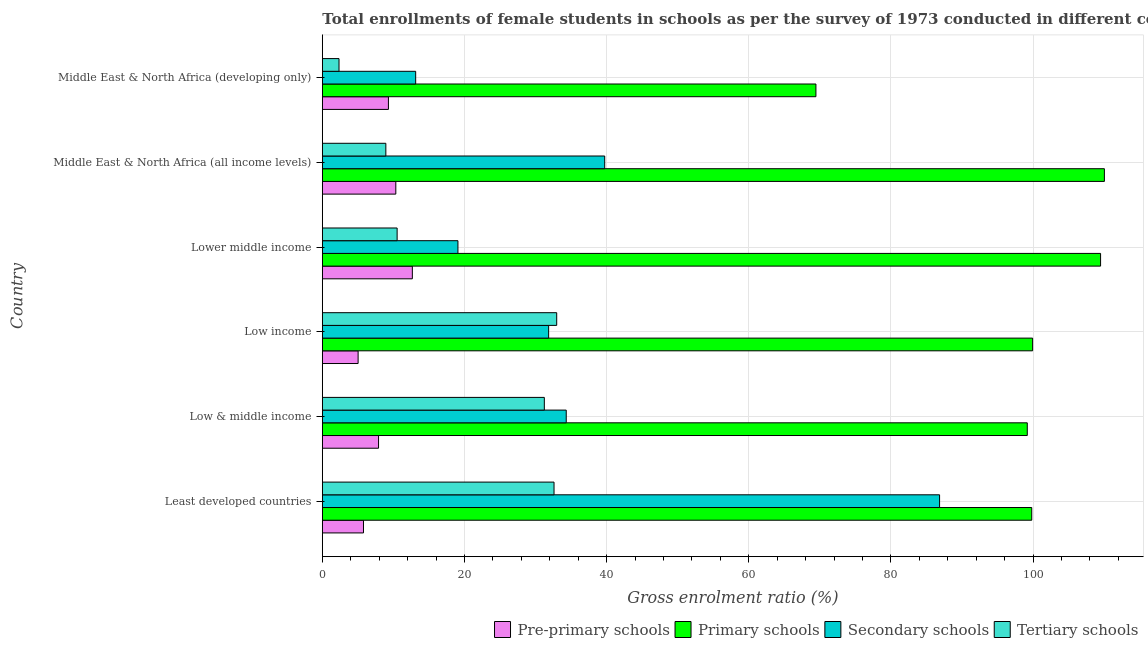How many groups of bars are there?
Offer a very short reply. 6. Are the number of bars per tick equal to the number of legend labels?
Offer a very short reply. Yes. How many bars are there on the 4th tick from the bottom?
Your answer should be very brief. 4. What is the label of the 1st group of bars from the top?
Your answer should be compact. Middle East & North Africa (developing only). In how many cases, is the number of bars for a given country not equal to the number of legend labels?
Offer a terse response. 0. What is the gross enrolment ratio(female) in primary schools in Low income?
Your answer should be very brief. 99.94. Across all countries, what is the maximum gross enrolment ratio(female) in secondary schools?
Make the answer very short. 86.85. Across all countries, what is the minimum gross enrolment ratio(female) in tertiary schools?
Offer a very short reply. 2.35. In which country was the gross enrolment ratio(female) in pre-primary schools maximum?
Give a very brief answer. Lower middle income. In which country was the gross enrolment ratio(female) in secondary schools minimum?
Give a very brief answer. Middle East & North Africa (developing only). What is the total gross enrolment ratio(female) in pre-primary schools in the graph?
Ensure brevity in your answer.  51.04. What is the difference between the gross enrolment ratio(female) in pre-primary schools in Low income and that in Lower middle income?
Your response must be concise. -7.63. What is the difference between the gross enrolment ratio(female) in secondary schools in Low income and the gross enrolment ratio(female) in primary schools in Middle East & North Africa (developing only)?
Provide a short and direct response. -37.61. What is the average gross enrolment ratio(female) in pre-primary schools per country?
Your answer should be very brief. 8.51. What is the difference between the gross enrolment ratio(female) in tertiary schools and gross enrolment ratio(female) in secondary schools in Low & middle income?
Offer a terse response. -3.08. In how many countries, is the gross enrolment ratio(female) in secondary schools greater than 64 %?
Your response must be concise. 1. What is the ratio of the gross enrolment ratio(female) in tertiary schools in Middle East & North Africa (all income levels) to that in Middle East & North Africa (developing only)?
Provide a succinct answer. 3.81. What is the difference between the highest and the second highest gross enrolment ratio(female) in tertiary schools?
Provide a short and direct response. 0.38. What is the difference between the highest and the lowest gross enrolment ratio(female) in primary schools?
Offer a very short reply. 40.59. Is the sum of the gross enrolment ratio(female) in tertiary schools in Low & middle income and Middle East & North Africa (all income levels) greater than the maximum gross enrolment ratio(female) in primary schools across all countries?
Offer a very short reply. No. Is it the case that in every country, the sum of the gross enrolment ratio(female) in tertiary schools and gross enrolment ratio(female) in primary schools is greater than the sum of gross enrolment ratio(female) in secondary schools and gross enrolment ratio(female) in pre-primary schools?
Your answer should be compact. Yes. What does the 4th bar from the top in Middle East & North Africa (developing only) represents?
Your answer should be compact. Pre-primary schools. What does the 3rd bar from the bottom in Middle East & North Africa (all income levels) represents?
Offer a very short reply. Secondary schools. Is it the case that in every country, the sum of the gross enrolment ratio(female) in pre-primary schools and gross enrolment ratio(female) in primary schools is greater than the gross enrolment ratio(female) in secondary schools?
Keep it short and to the point. Yes. How many countries are there in the graph?
Offer a terse response. 6. Are the values on the major ticks of X-axis written in scientific E-notation?
Keep it short and to the point. No. Does the graph contain any zero values?
Ensure brevity in your answer.  No. Does the graph contain grids?
Provide a short and direct response. Yes. What is the title of the graph?
Offer a very short reply. Total enrollments of female students in schools as per the survey of 1973 conducted in different countries. Does "Rule based governance" appear as one of the legend labels in the graph?
Your response must be concise. No. What is the label or title of the X-axis?
Provide a succinct answer. Gross enrolment ratio (%). What is the Gross enrolment ratio (%) of Pre-primary schools in Least developed countries?
Ensure brevity in your answer.  5.79. What is the Gross enrolment ratio (%) of Primary schools in Least developed countries?
Make the answer very short. 99.82. What is the Gross enrolment ratio (%) of Secondary schools in Least developed countries?
Provide a short and direct response. 86.85. What is the Gross enrolment ratio (%) in Tertiary schools in Least developed countries?
Offer a very short reply. 32.6. What is the Gross enrolment ratio (%) in Pre-primary schools in Low & middle income?
Offer a terse response. 7.91. What is the Gross enrolment ratio (%) in Primary schools in Low & middle income?
Make the answer very short. 99.19. What is the Gross enrolment ratio (%) in Secondary schools in Low & middle income?
Your answer should be very brief. 34.32. What is the Gross enrolment ratio (%) in Tertiary schools in Low & middle income?
Your answer should be very brief. 31.24. What is the Gross enrolment ratio (%) of Pre-primary schools in Low income?
Make the answer very short. 5.04. What is the Gross enrolment ratio (%) of Primary schools in Low income?
Offer a terse response. 99.94. What is the Gross enrolment ratio (%) of Secondary schools in Low income?
Make the answer very short. 31.84. What is the Gross enrolment ratio (%) in Tertiary schools in Low income?
Your answer should be very brief. 32.98. What is the Gross enrolment ratio (%) in Pre-primary schools in Lower middle income?
Offer a terse response. 12.67. What is the Gross enrolment ratio (%) in Primary schools in Lower middle income?
Ensure brevity in your answer.  109.51. What is the Gross enrolment ratio (%) of Secondary schools in Lower middle income?
Your response must be concise. 19.08. What is the Gross enrolment ratio (%) in Tertiary schools in Lower middle income?
Your answer should be very brief. 10.52. What is the Gross enrolment ratio (%) in Pre-primary schools in Middle East & North Africa (all income levels)?
Ensure brevity in your answer.  10.34. What is the Gross enrolment ratio (%) of Primary schools in Middle East & North Africa (all income levels)?
Offer a very short reply. 110.04. What is the Gross enrolment ratio (%) in Secondary schools in Middle East & North Africa (all income levels)?
Keep it short and to the point. 39.73. What is the Gross enrolment ratio (%) in Tertiary schools in Middle East & North Africa (all income levels)?
Ensure brevity in your answer.  8.94. What is the Gross enrolment ratio (%) in Pre-primary schools in Middle East & North Africa (developing only)?
Ensure brevity in your answer.  9.3. What is the Gross enrolment ratio (%) of Primary schools in Middle East & North Africa (developing only)?
Your answer should be compact. 69.45. What is the Gross enrolment ratio (%) of Secondary schools in Middle East & North Africa (developing only)?
Ensure brevity in your answer.  13.13. What is the Gross enrolment ratio (%) of Tertiary schools in Middle East & North Africa (developing only)?
Offer a very short reply. 2.35. Across all countries, what is the maximum Gross enrolment ratio (%) of Pre-primary schools?
Ensure brevity in your answer.  12.67. Across all countries, what is the maximum Gross enrolment ratio (%) in Primary schools?
Offer a very short reply. 110.04. Across all countries, what is the maximum Gross enrolment ratio (%) of Secondary schools?
Give a very brief answer. 86.85. Across all countries, what is the maximum Gross enrolment ratio (%) of Tertiary schools?
Make the answer very short. 32.98. Across all countries, what is the minimum Gross enrolment ratio (%) in Pre-primary schools?
Keep it short and to the point. 5.04. Across all countries, what is the minimum Gross enrolment ratio (%) of Primary schools?
Your answer should be very brief. 69.45. Across all countries, what is the minimum Gross enrolment ratio (%) of Secondary schools?
Ensure brevity in your answer.  13.13. Across all countries, what is the minimum Gross enrolment ratio (%) of Tertiary schools?
Ensure brevity in your answer.  2.35. What is the total Gross enrolment ratio (%) in Pre-primary schools in the graph?
Ensure brevity in your answer.  51.04. What is the total Gross enrolment ratio (%) of Primary schools in the graph?
Provide a succinct answer. 587.96. What is the total Gross enrolment ratio (%) of Secondary schools in the graph?
Your answer should be compact. 224.96. What is the total Gross enrolment ratio (%) in Tertiary schools in the graph?
Keep it short and to the point. 118.63. What is the difference between the Gross enrolment ratio (%) in Pre-primary schools in Least developed countries and that in Low & middle income?
Provide a short and direct response. -2.12. What is the difference between the Gross enrolment ratio (%) in Primary schools in Least developed countries and that in Low & middle income?
Keep it short and to the point. 0.63. What is the difference between the Gross enrolment ratio (%) of Secondary schools in Least developed countries and that in Low & middle income?
Make the answer very short. 52.53. What is the difference between the Gross enrolment ratio (%) in Tertiary schools in Least developed countries and that in Low & middle income?
Make the answer very short. 1.36. What is the difference between the Gross enrolment ratio (%) of Pre-primary schools in Least developed countries and that in Low income?
Give a very brief answer. 0.76. What is the difference between the Gross enrolment ratio (%) of Primary schools in Least developed countries and that in Low income?
Offer a very short reply. -0.12. What is the difference between the Gross enrolment ratio (%) in Secondary schools in Least developed countries and that in Low income?
Your answer should be very brief. 55.01. What is the difference between the Gross enrolment ratio (%) in Tertiary schools in Least developed countries and that in Low income?
Offer a very short reply. -0.38. What is the difference between the Gross enrolment ratio (%) of Pre-primary schools in Least developed countries and that in Lower middle income?
Ensure brevity in your answer.  -6.88. What is the difference between the Gross enrolment ratio (%) of Primary schools in Least developed countries and that in Lower middle income?
Give a very brief answer. -9.68. What is the difference between the Gross enrolment ratio (%) in Secondary schools in Least developed countries and that in Lower middle income?
Ensure brevity in your answer.  67.77. What is the difference between the Gross enrolment ratio (%) in Tertiary schools in Least developed countries and that in Lower middle income?
Your answer should be compact. 22.08. What is the difference between the Gross enrolment ratio (%) of Pre-primary schools in Least developed countries and that in Middle East & North Africa (all income levels)?
Your answer should be compact. -4.55. What is the difference between the Gross enrolment ratio (%) of Primary schools in Least developed countries and that in Middle East & North Africa (all income levels)?
Give a very brief answer. -10.22. What is the difference between the Gross enrolment ratio (%) in Secondary schools in Least developed countries and that in Middle East & North Africa (all income levels)?
Provide a succinct answer. 47.12. What is the difference between the Gross enrolment ratio (%) of Tertiary schools in Least developed countries and that in Middle East & North Africa (all income levels)?
Make the answer very short. 23.66. What is the difference between the Gross enrolment ratio (%) of Pre-primary schools in Least developed countries and that in Middle East & North Africa (developing only)?
Provide a short and direct response. -3.51. What is the difference between the Gross enrolment ratio (%) in Primary schools in Least developed countries and that in Middle East & North Africa (developing only)?
Offer a terse response. 30.37. What is the difference between the Gross enrolment ratio (%) of Secondary schools in Least developed countries and that in Middle East & North Africa (developing only)?
Keep it short and to the point. 73.72. What is the difference between the Gross enrolment ratio (%) in Tertiary schools in Least developed countries and that in Middle East & North Africa (developing only)?
Keep it short and to the point. 30.25. What is the difference between the Gross enrolment ratio (%) in Pre-primary schools in Low & middle income and that in Low income?
Offer a very short reply. 2.87. What is the difference between the Gross enrolment ratio (%) of Primary schools in Low & middle income and that in Low income?
Your response must be concise. -0.75. What is the difference between the Gross enrolment ratio (%) of Secondary schools in Low & middle income and that in Low income?
Make the answer very short. 2.48. What is the difference between the Gross enrolment ratio (%) in Tertiary schools in Low & middle income and that in Low income?
Your answer should be compact. -1.74. What is the difference between the Gross enrolment ratio (%) of Pre-primary schools in Low & middle income and that in Lower middle income?
Keep it short and to the point. -4.76. What is the difference between the Gross enrolment ratio (%) in Primary schools in Low & middle income and that in Lower middle income?
Your answer should be very brief. -10.31. What is the difference between the Gross enrolment ratio (%) in Secondary schools in Low & middle income and that in Lower middle income?
Offer a very short reply. 15.24. What is the difference between the Gross enrolment ratio (%) in Tertiary schools in Low & middle income and that in Lower middle income?
Offer a terse response. 20.71. What is the difference between the Gross enrolment ratio (%) of Pre-primary schools in Low & middle income and that in Middle East & North Africa (all income levels)?
Your answer should be very brief. -2.43. What is the difference between the Gross enrolment ratio (%) of Primary schools in Low & middle income and that in Middle East & North Africa (all income levels)?
Make the answer very short. -10.85. What is the difference between the Gross enrolment ratio (%) in Secondary schools in Low & middle income and that in Middle East & North Africa (all income levels)?
Make the answer very short. -5.41. What is the difference between the Gross enrolment ratio (%) of Tertiary schools in Low & middle income and that in Middle East & North Africa (all income levels)?
Offer a terse response. 22.3. What is the difference between the Gross enrolment ratio (%) in Pre-primary schools in Low & middle income and that in Middle East & North Africa (developing only)?
Make the answer very short. -1.39. What is the difference between the Gross enrolment ratio (%) of Primary schools in Low & middle income and that in Middle East & North Africa (developing only)?
Provide a succinct answer. 29.74. What is the difference between the Gross enrolment ratio (%) in Secondary schools in Low & middle income and that in Middle East & North Africa (developing only)?
Your response must be concise. 21.18. What is the difference between the Gross enrolment ratio (%) of Tertiary schools in Low & middle income and that in Middle East & North Africa (developing only)?
Keep it short and to the point. 28.89. What is the difference between the Gross enrolment ratio (%) of Pre-primary schools in Low income and that in Lower middle income?
Ensure brevity in your answer.  -7.63. What is the difference between the Gross enrolment ratio (%) in Primary schools in Low income and that in Lower middle income?
Offer a very short reply. -9.56. What is the difference between the Gross enrolment ratio (%) in Secondary schools in Low income and that in Lower middle income?
Offer a very short reply. 12.76. What is the difference between the Gross enrolment ratio (%) in Tertiary schools in Low income and that in Lower middle income?
Ensure brevity in your answer.  22.45. What is the difference between the Gross enrolment ratio (%) in Pre-primary schools in Low income and that in Middle East & North Africa (all income levels)?
Keep it short and to the point. -5.3. What is the difference between the Gross enrolment ratio (%) of Primary schools in Low income and that in Middle East & North Africa (all income levels)?
Ensure brevity in your answer.  -10.1. What is the difference between the Gross enrolment ratio (%) of Secondary schools in Low income and that in Middle East & North Africa (all income levels)?
Ensure brevity in your answer.  -7.89. What is the difference between the Gross enrolment ratio (%) in Tertiary schools in Low income and that in Middle East & North Africa (all income levels)?
Provide a succinct answer. 24.04. What is the difference between the Gross enrolment ratio (%) in Pre-primary schools in Low income and that in Middle East & North Africa (developing only)?
Offer a terse response. -4.26. What is the difference between the Gross enrolment ratio (%) in Primary schools in Low income and that in Middle East & North Africa (developing only)?
Offer a terse response. 30.49. What is the difference between the Gross enrolment ratio (%) in Secondary schools in Low income and that in Middle East & North Africa (developing only)?
Your answer should be very brief. 18.71. What is the difference between the Gross enrolment ratio (%) of Tertiary schools in Low income and that in Middle East & North Africa (developing only)?
Ensure brevity in your answer.  30.63. What is the difference between the Gross enrolment ratio (%) of Pre-primary schools in Lower middle income and that in Middle East & North Africa (all income levels)?
Give a very brief answer. 2.33. What is the difference between the Gross enrolment ratio (%) of Primary schools in Lower middle income and that in Middle East & North Africa (all income levels)?
Your answer should be very brief. -0.54. What is the difference between the Gross enrolment ratio (%) of Secondary schools in Lower middle income and that in Middle East & North Africa (all income levels)?
Your answer should be very brief. -20.65. What is the difference between the Gross enrolment ratio (%) of Tertiary schools in Lower middle income and that in Middle East & North Africa (all income levels)?
Your answer should be compact. 1.59. What is the difference between the Gross enrolment ratio (%) in Pre-primary schools in Lower middle income and that in Middle East & North Africa (developing only)?
Offer a very short reply. 3.37. What is the difference between the Gross enrolment ratio (%) in Primary schools in Lower middle income and that in Middle East & North Africa (developing only)?
Offer a very short reply. 40.05. What is the difference between the Gross enrolment ratio (%) of Secondary schools in Lower middle income and that in Middle East & North Africa (developing only)?
Offer a terse response. 5.95. What is the difference between the Gross enrolment ratio (%) in Tertiary schools in Lower middle income and that in Middle East & North Africa (developing only)?
Ensure brevity in your answer.  8.18. What is the difference between the Gross enrolment ratio (%) in Pre-primary schools in Middle East & North Africa (all income levels) and that in Middle East & North Africa (developing only)?
Your response must be concise. 1.04. What is the difference between the Gross enrolment ratio (%) of Primary schools in Middle East & North Africa (all income levels) and that in Middle East & North Africa (developing only)?
Provide a succinct answer. 40.59. What is the difference between the Gross enrolment ratio (%) of Secondary schools in Middle East & North Africa (all income levels) and that in Middle East & North Africa (developing only)?
Give a very brief answer. 26.6. What is the difference between the Gross enrolment ratio (%) of Tertiary schools in Middle East & North Africa (all income levels) and that in Middle East & North Africa (developing only)?
Keep it short and to the point. 6.59. What is the difference between the Gross enrolment ratio (%) of Pre-primary schools in Least developed countries and the Gross enrolment ratio (%) of Primary schools in Low & middle income?
Your answer should be very brief. -93.4. What is the difference between the Gross enrolment ratio (%) in Pre-primary schools in Least developed countries and the Gross enrolment ratio (%) in Secondary schools in Low & middle income?
Provide a short and direct response. -28.53. What is the difference between the Gross enrolment ratio (%) of Pre-primary schools in Least developed countries and the Gross enrolment ratio (%) of Tertiary schools in Low & middle income?
Offer a very short reply. -25.45. What is the difference between the Gross enrolment ratio (%) of Primary schools in Least developed countries and the Gross enrolment ratio (%) of Secondary schools in Low & middle income?
Your answer should be compact. 65.5. What is the difference between the Gross enrolment ratio (%) in Primary schools in Least developed countries and the Gross enrolment ratio (%) in Tertiary schools in Low & middle income?
Provide a succinct answer. 68.58. What is the difference between the Gross enrolment ratio (%) in Secondary schools in Least developed countries and the Gross enrolment ratio (%) in Tertiary schools in Low & middle income?
Make the answer very short. 55.62. What is the difference between the Gross enrolment ratio (%) in Pre-primary schools in Least developed countries and the Gross enrolment ratio (%) in Primary schools in Low income?
Your answer should be compact. -94.15. What is the difference between the Gross enrolment ratio (%) of Pre-primary schools in Least developed countries and the Gross enrolment ratio (%) of Secondary schools in Low income?
Provide a short and direct response. -26.05. What is the difference between the Gross enrolment ratio (%) in Pre-primary schools in Least developed countries and the Gross enrolment ratio (%) in Tertiary schools in Low income?
Make the answer very short. -27.19. What is the difference between the Gross enrolment ratio (%) in Primary schools in Least developed countries and the Gross enrolment ratio (%) in Secondary schools in Low income?
Your answer should be compact. 67.98. What is the difference between the Gross enrolment ratio (%) of Primary schools in Least developed countries and the Gross enrolment ratio (%) of Tertiary schools in Low income?
Ensure brevity in your answer.  66.84. What is the difference between the Gross enrolment ratio (%) in Secondary schools in Least developed countries and the Gross enrolment ratio (%) in Tertiary schools in Low income?
Provide a short and direct response. 53.87. What is the difference between the Gross enrolment ratio (%) of Pre-primary schools in Least developed countries and the Gross enrolment ratio (%) of Primary schools in Lower middle income?
Your answer should be very brief. -103.71. What is the difference between the Gross enrolment ratio (%) in Pre-primary schools in Least developed countries and the Gross enrolment ratio (%) in Secondary schools in Lower middle income?
Keep it short and to the point. -13.29. What is the difference between the Gross enrolment ratio (%) in Pre-primary schools in Least developed countries and the Gross enrolment ratio (%) in Tertiary schools in Lower middle income?
Offer a very short reply. -4.73. What is the difference between the Gross enrolment ratio (%) of Primary schools in Least developed countries and the Gross enrolment ratio (%) of Secondary schools in Lower middle income?
Provide a succinct answer. 80.74. What is the difference between the Gross enrolment ratio (%) in Primary schools in Least developed countries and the Gross enrolment ratio (%) in Tertiary schools in Lower middle income?
Your answer should be compact. 89.3. What is the difference between the Gross enrolment ratio (%) of Secondary schools in Least developed countries and the Gross enrolment ratio (%) of Tertiary schools in Lower middle income?
Ensure brevity in your answer.  76.33. What is the difference between the Gross enrolment ratio (%) in Pre-primary schools in Least developed countries and the Gross enrolment ratio (%) in Primary schools in Middle East & North Africa (all income levels)?
Offer a very short reply. -104.25. What is the difference between the Gross enrolment ratio (%) of Pre-primary schools in Least developed countries and the Gross enrolment ratio (%) of Secondary schools in Middle East & North Africa (all income levels)?
Your answer should be compact. -33.94. What is the difference between the Gross enrolment ratio (%) of Pre-primary schools in Least developed countries and the Gross enrolment ratio (%) of Tertiary schools in Middle East & North Africa (all income levels)?
Provide a short and direct response. -3.15. What is the difference between the Gross enrolment ratio (%) of Primary schools in Least developed countries and the Gross enrolment ratio (%) of Secondary schools in Middle East & North Africa (all income levels)?
Make the answer very short. 60.09. What is the difference between the Gross enrolment ratio (%) in Primary schools in Least developed countries and the Gross enrolment ratio (%) in Tertiary schools in Middle East & North Africa (all income levels)?
Provide a succinct answer. 90.88. What is the difference between the Gross enrolment ratio (%) of Secondary schools in Least developed countries and the Gross enrolment ratio (%) of Tertiary schools in Middle East & North Africa (all income levels)?
Ensure brevity in your answer.  77.91. What is the difference between the Gross enrolment ratio (%) in Pre-primary schools in Least developed countries and the Gross enrolment ratio (%) in Primary schools in Middle East & North Africa (developing only)?
Provide a succinct answer. -63.66. What is the difference between the Gross enrolment ratio (%) of Pre-primary schools in Least developed countries and the Gross enrolment ratio (%) of Secondary schools in Middle East & North Africa (developing only)?
Provide a succinct answer. -7.34. What is the difference between the Gross enrolment ratio (%) in Pre-primary schools in Least developed countries and the Gross enrolment ratio (%) in Tertiary schools in Middle East & North Africa (developing only)?
Offer a very short reply. 3.44. What is the difference between the Gross enrolment ratio (%) of Primary schools in Least developed countries and the Gross enrolment ratio (%) of Secondary schools in Middle East & North Africa (developing only)?
Provide a succinct answer. 86.69. What is the difference between the Gross enrolment ratio (%) in Primary schools in Least developed countries and the Gross enrolment ratio (%) in Tertiary schools in Middle East & North Africa (developing only)?
Your answer should be compact. 97.47. What is the difference between the Gross enrolment ratio (%) in Secondary schools in Least developed countries and the Gross enrolment ratio (%) in Tertiary schools in Middle East & North Africa (developing only)?
Keep it short and to the point. 84.5. What is the difference between the Gross enrolment ratio (%) of Pre-primary schools in Low & middle income and the Gross enrolment ratio (%) of Primary schools in Low income?
Offer a terse response. -92.03. What is the difference between the Gross enrolment ratio (%) of Pre-primary schools in Low & middle income and the Gross enrolment ratio (%) of Secondary schools in Low income?
Your answer should be compact. -23.93. What is the difference between the Gross enrolment ratio (%) in Pre-primary schools in Low & middle income and the Gross enrolment ratio (%) in Tertiary schools in Low income?
Ensure brevity in your answer.  -25.07. What is the difference between the Gross enrolment ratio (%) of Primary schools in Low & middle income and the Gross enrolment ratio (%) of Secondary schools in Low income?
Ensure brevity in your answer.  67.35. What is the difference between the Gross enrolment ratio (%) in Primary schools in Low & middle income and the Gross enrolment ratio (%) in Tertiary schools in Low income?
Provide a short and direct response. 66.21. What is the difference between the Gross enrolment ratio (%) of Secondary schools in Low & middle income and the Gross enrolment ratio (%) of Tertiary schools in Low income?
Make the answer very short. 1.34. What is the difference between the Gross enrolment ratio (%) in Pre-primary schools in Low & middle income and the Gross enrolment ratio (%) in Primary schools in Lower middle income?
Your answer should be very brief. -101.6. What is the difference between the Gross enrolment ratio (%) in Pre-primary schools in Low & middle income and the Gross enrolment ratio (%) in Secondary schools in Lower middle income?
Offer a very short reply. -11.17. What is the difference between the Gross enrolment ratio (%) of Pre-primary schools in Low & middle income and the Gross enrolment ratio (%) of Tertiary schools in Lower middle income?
Your response must be concise. -2.62. What is the difference between the Gross enrolment ratio (%) in Primary schools in Low & middle income and the Gross enrolment ratio (%) in Secondary schools in Lower middle income?
Your answer should be compact. 80.11. What is the difference between the Gross enrolment ratio (%) in Primary schools in Low & middle income and the Gross enrolment ratio (%) in Tertiary schools in Lower middle income?
Offer a very short reply. 88.67. What is the difference between the Gross enrolment ratio (%) of Secondary schools in Low & middle income and the Gross enrolment ratio (%) of Tertiary schools in Lower middle income?
Offer a very short reply. 23.79. What is the difference between the Gross enrolment ratio (%) in Pre-primary schools in Low & middle income and the Gross enrolment ratio (%) in Primary schools in Middle East & North Africa (all income levels)?
Your response must be concise. -102.13. What is the difference between the Gross enrolment ratio (%) in Pre-primary schools in Low & middle income and the Gross enrolment ratio (%) in Secondary schools in Middle East & North Africa (all income levels)?
Give a very brief answer. -31.82. What is the difference between the Gross enrolment ratio (%) in Pre-primary schools in Low & middle income and the Gross enrolment ratio (%) in Tertiary schools in Middle East & North Africa (all income levels)?
Give a very brief answer. -1.03. What is the difference between the Gross enrolment ratio (%) of Primary schools in Low & middle income and the Gross enrolment ratio (%) of Secondary schools in Middle East & North Africa (all income levels)?
Provide a succinct answer. 59.46. What is the difference between the Gross enrolment ratio (%) in Primary schools in Low & middle income and the Gross enrolment ratio (%) in Tertiary schools in Middle East & North Africa (all income levels)?
Provide a succinct answer. 90.25. What is the difference between the Gross enrolment ratio (%) in Secondary schools in Low & middle income and the Gross enrolment ratio (%) in Tertiary schools in Middle East & North Africa (all income levels)?
Your response must be concise. 25.38. What is the difference between the Gross enrolment ratio (%) of Pre-primary schools in Low & middle income and the Gross enrolment ratio (%) of Primary schools in Middle East & North Africa (developing only)?
Your answer should be very brief. -61.54. What is the difference between the Gross enrolment ratio (%) in Pre-primary schools in Low & middle income and the Gross enrolment ratio (%) in Secondary schools in Middle East & North Africa (developing only)?
Your response must be concise. -5.22. What is the difference between the Gross enrolment ratio (%) in Pre-primary schools in Low & middle income and the Gross enrolment ratio (%) in Tertiary schools in Middle East & North Africa (developing only)?
Give a very brief answer. 5.56. What is the difference between the Gross enrolment ratio (%) in Primary schools in Low & middle income and the Gross enrolment ratio (%) in Secondary schools in Middle East & North Africa (developing only)?
Give a very brief answer. 86.06. What is the difference between the Gross enrolment ratio (%) in Primary schools in Low & middle income and the Gross enrolment ratio (%) in Tertiary schools in Middle East & North Africa (developing only)?
Make the answer very short. 96.84. What is the difference between the Gross enrolment ratio (%) in Secondary schools in Low & middle income and the Gross enrolment ratio (%) in Tertiary schools in Middle East & North Africa (developing only)?
Ensure brevity in your answer.  31.97. What is the difference between the Gross enrolment ratio (%) of Pre-primary schools in Low income and the Gross enrolment ratio (%) of Primary schools in Lower middle income?
Your response must be concise. -104.47. What is the difference between the Gross enrolment ratio (%) of Pre-primary schools in Low income and the Gross enrolment ratio (%) of Secondary schools in Lower middle income?
Your answer should be very brief. -14.04. What is the difference between the Gross enrolment ratio (%) of Pre-primary schools in Low income and the Gross enrolment ratio (%) of Tertiary schools in Lower middle income?
Provide a succinct answer. -5.49. What is the difference between the Gross enrolment ratio (%) of Primary schools in Low income and the Gross enrolment ratio (%) of Secondary schools in Lower middle income?
Offer a very short reply. 80.86. What is the difference between the Gross enrolment ratio (%) in Primary schools in Low income and the Gross enrolment ratio (%) in Tertiary schools in Lower middle income?
Your answer should be compact. 89.42. What is the difference between the Gross enrolment ratio (%) in Secondary schools in Low income and the Gross enrolment ratio (%) in Tertiary schools in Lower middle income?
Give a very brief answer. 21.32. What is the difference between the Gross enrolment ratio (%) in Pre-primary schools in Low income and the Gross enrolment ratio (%) in Primary schools in Middle East & North Africa (all income levels)?
Provide a short and direct response. -105.01. What is the difference between the Gross enrolment ratio (%) in Pre-primary schools in Low income and the Gross enrolment ratio (%) in Secondary schools in Middle East & North Africa (all income levels)?
Your answer should be very brief. -34.7. What is the difference between the Gross enrolment ratio (%) of Pre-primary schools in Low income and the Gross enrolment ratio (%) of Tertiary schools in Middle East & North Africa (all income levels)?
Give a very brief answer. -3.9. What is the difference between the Gross enrolment ratio (%) of Primary schools in Low income and the Gross enrolment ratio (%) of Secondary schools in Middle East & North Africa (all income levels)?
Provide a short and direct response. 60.21. What is the difference between the Gross enrolment ratio (%) in Primary schools in Low income and the Gross enrolment ratio (%) in Tertiary schools in Middle East & North Africa (all income levels)?
Offer a terse response. 91.01. What is the difference between the Gross enrolment ratio (%) of Secondary schools in Low income and the Gross enrolment ratio (%) of Tertiary schools in Middle East & North Africa (all income levels)?
Provide a short and direct response. 22.91. What is the difference between the Gross enrolment ratio (%) of Pre-primary schools in Low income and the Gross enrolment ratio (%) of Primary schools in Middle East & North Africa (developing only)?
Give a very brief answer. -64.42. What is the difference between the Gross enrolment ratio (%) of Pre-primary schools in Low income and the Gross enrolment ratio (%) of Secondary schools in Middle East & North Africa (developing only)?
Make the answer very short. -8.1. What is the difference between the Gross enrolment ratio (%) of Pre-primary schools in Low income and the Gross enrolment ratio (%) of Tertiary schools in Middle East & North Africa (developing only)?
Ensure brevity in your answer.  2.69. What is the difference between the Gross enrolment ratio (%) of Primary schools in Low income and the Gross enrolment ratio (%) of Secondary schools in Middle East & North Africa (developing only)?
Your answer should be compact. 86.81. What is the difference between the Gross enrolment ratio (%) in Primary schools in Low income and the Gross enrolment ratio (%) in Tertiary schools in Middle East & North Africa (developing only)?
Give a very brief answer. 97.6. What is the difference between the Gross enrolment ratio (%) of Secondary schools in Low income and the Gross enrolment ratio (%) of Tertiary schools in Middle East & North Africa (developing only)?
Provide a short and direct response. 29.5. What is the difference between the Gross enrolment ratio (%) in Pre-primary schools in Lower middle income and the Gross enrolment ratio (%) in Primary schools in Middle East & North Africa (all income levels)?
Your answer should be very brief. -97.38. What is the difference between the Gross enrolment ratio (%) of Pre-primary schools in Lower middle income and the Gross enrolment ratio (%) of Secondary schools in Middle East & North Africa (all income levels)?
Your response must be concise. -27.07. What is the difference between the Gross enrolment ratio (%) in Pre-primary schools in Lower middle income and the Gross enrolment ratio (%) in Tertiary schools in Middle East & North Africa (all income levels)?
Offer a terse response. 3.73. What is the difference between the Gross enrolment ratio (%) of Primary schools in Lower middle income and the Gross enrolment ratio (%) of Secondary schools in Middle East & North Africa (all income levels)?
Your answer should be very brief. 69.77. What is the difference between the Gross enrolment ratio (%) in Primary schools in Lower middle income and the Gross enrolment ratio (%) in Tertiary schools in Middle East & North Africa (all income levels)?
Your answer should be very brief. 100.57. What is the difference between the Gross enrolment ratio (%) in Secondary schools in Lower middle income and the Gross enrolment ratio (%) in Tertiary schools in Middle East & North Africa (all income levels)?
Your answer should be very brief. 10.14. What is the difference between the Gross enrolment ratio (%) of Pre-primary schools in Lower middle income and the Gross enrolment ratio (%) of Primary schools in Middle East & North Africa (developing only)?
Give a very brief answer. -56.78. What is the difference between the Gross enrolment ratio (%) of Pre-primary schools in Lower middle income and the Gross enrolment ratio (%) of Secondary schools in Middle East & North Africa (developing only)?
Offer a very short reply. -0.47. What is the difference between the Gross enrolment ratio (%) of Pre-primary schools in Lower middle income and the Gross enrolment ratio (%) of Tertiary schools in Middle East & North Africa (developing only)?
Give a very brief answer. 10.32. What is the difference between the Gross enrolment ratio (%) in Primary schools in Lower middle income and the Gross enrolment ratio (%) in Secondary schools in Middle East & North Africa (developing only)?
Make the answer very short. 96.37. What is the difference between the Gross enrolment ratio (%) of Primary schools in Lower middle income and the Gross enrolment ratio (%) of Tertiary schools in Middle East & North Africa (developing only)?
Provide a succinct answer. 107.16. What is the difference between the Gross enrolment ratio (%) in Secondary schools in Lower middle income and the Gross enrolment ratio (%) in Tertiary schools in Middle East & North Africa (developing only)?
Your answer should be compact. 16.73. What is the difference between the Gross enrolment ratio (%) of Pre-primary schools in Middle East & North Africa (all income levels) and the Gross enrolment ratio (%) of Primary schools in Middle East & North Africa (developing only)?
Your answer should be compact. -59.11. What is the difference between the Gross enrolment ratio (%) of Pre-primary schools in Middle East & North Africa (all income levels) and the Gross enrolment ratio (%) of Secondary schools in Middle East & North Africa (developing only)?
Keep it short and to the point. -2.8. What is the difference between the Gross enrolment ratio (%) in Pre-primary schools in Middle East & North Africa (all income levels) and the Gross enrolment ratio (%) in Tertiary schools in Middle East & North Africa (developing only)?
Your response must be concise. 7.99. What is the difference between the Gross enrolment ratio (%) of Primary schools in Middle East & North Africa (all income levels) and the Gross enrolment ratio (%) of Secondary schools in Middle East & North Africa (developing only)?
Make the answer very short. 96.91. What is the difference between the Gross enrolment ratio (%) in Primary schools in Middle East & North Africa (all income levels) and the Gross enrolment ratio (%) in Tertiary schools in Middle East & North Africa (developing only)?
Give a very brief answer. 107.69. What is the difference between the Gross enrolment ratio (%) of Secondary schools in Middle East & North Africa (all income levels) and the Gross enrolment ratio (%) of Tertiary schools in Middle East & North Africa (developing only)?
Offer a terse response. 37.38. What is the average Gross enrolment ratio (%) of Pre-primary schools per country?
Your response must be concise. 8.51. What is the average Gross enrolment ratio (%) in Primary schools per country?
Keep it short and to the point. 97.99. What is the average Gross enrolment ratio (%) of Secondary schools per country?
Offer a terse response. 37.49. What is the average Gross enrolment ratio (%) of Tertiary schools per country?
Offer a very short reply. 19.77. What is the difference between the Gross enrolment ratio (%) of Pre-primary schools and Gross enrolment ratio (%) of Primary schools in Least developed countries?
Keep it short and to the point. -94.03. What is the difference between the Gross enrolment ratio (%) in Pre-primary schools and Gross enrolment ratio (%) in Secondary schools in Least developed countries?
Keep it short and to the point. -81.06. What is the difference between the Gross enrolment ratio (%) in Pre-primary schools and Gross enrolment ratio (%) in Tertiary schools in Least developed countries?
Make the answer very short. -26.81. What is the difference between the Gross enrolment ratio (%) of Primary schools and Gross enrolment ratio (%) of Secondary schools in Least developed countries?
Your answer should be very brief. 12.97. What is the difference between the Gross enrolment ratio (%) in Primary schools and Gross enrolment ratio (%) in Tertiary schools in Least developed countries?
Your response must be concise. 67.22. What is the difference between the Gross enrolment ratio (%) of Secondary schools and Gross enrolment ratio (%) of Tertiary schools in Least developed countries?
Provide a succinct answer. 54.25. What is the difference between the Gross enrolment ratio (%) in Pre-primary schools and Gross enrolment ratio (%) in Primary schools in Low & middle income?
Give a very brief answer. -91.28. What is the difference between the Gross enrolment ratio (%) in Pre-primary schools and Gross enrolment ratio (%) in Secondary schools in Low & middle income?
Offer a terse response. -26.41. What is the difference between the Gross enrolment ratio (%) in Pre-primary schools and Gross enrolment ratio (%) in Tertiary schools in Low & middle income?
Provide a short and direct response. -23.33. What is the difference between the Gross enrolment ratio (%) of Primary schools and Gross enrolment ratio (%) of Secondary schools in Low & middle income?
Your answer should be compact. 64.87. What is the difference between the Gross enrolment ratio (%) in Primary schools and Gross enrolment ratio (%) in Tertiary schools in Low & middle income?
Offer a very short reply. 67.95. What is the difference between the Gross enrolment ratio (%) in Secondary schools and Gross enrolment ratio (%) in Tertiary schools in Low & middle income?
Keep it short and to the point. 3.08. What is the difference between the Gross enrolment ratio (%) of Pre-primary schools and Gross enrolment ratio (%) of Primary schools in Low income?
Your answer should be very brief. -94.91. What is the difference between the Gross enrolment ratio (%) in Pre-primary schools and Gross enrolment ratio (%) in Secondary schools in Low income?
Offer a terse response. -26.81. What is the difference between the Gross enrolment ratio (%) of Pre-primary schools and Gross enrolment ratio (%) of Tertiary schools in Low income?
Your response must be concise. -27.94. What is the difference between the Gross enrolment ratio (%) of Primary schools and Gross enrolment ratio (%) of Secondary schools in Low income?
Your answer should be very brief. 68.1. What is the difference between the Gross enrolment ratio (%) in Primary schools and Gross enrolment ratio (%) in Tertiary schools in Low income?
Offer a terse response. 66.97. What is the difference between the Gross enrolment ratio (%) in Secondary schools and Gross enrolment ratio (%) in Tertiary schools in Low income?
Your response must be concise. -1.14. What is the difference between the Gross enrolment ratio (%) in Pre-primary schools and Gross enrolment ratio (%) in Primary schools in Lower middle income?
Ensure brevity in your answer.  -96.84. What is the difference between the Gross enrolment ratio (%) in Pre-primary schools and Gross enrolment ratio (%) in Secondary schools in Lower middle income?
Keep it short and to the point. -6.41. What is the difference between the Gross enrolment ratio (%) of Pre-primary schools and Gross enrolment ratio (%) of Tertiary schools in Lower middle income?
Offer a very short reply. 2.14. What is the difference between the Gross enrolment ratio (%) of Primary schools and Gross enrolment ratio (%) of Secondary schools in Lower middle income?
Make the answer very short. 90.43. What is the difference between the Gross enrolment ratio (%) in Primary schools and Gross enrolment ratio (%) in Tertiary schools in Lower middle income?
Provide a succinct answer. 98.98. What is the difference between the Gross enrolment ratio (%) in Secondary schools and Gross enrolment ratio (%) in Tertiary schools in Lower middle income?
Your answer should be compact. 8.56. What is the difference between the Gross enrolment ratio (%) of Pre-primary schools and Gross enrolment ratio (%) of Primary schools in Middle East & North Africa (all income levels)?
Keep it short and to the point. -99.7. What is the difference between the Gross enrolment ratio (%) of Pre-primary schools and Gross enrolment ratio (%) of Secondary schools in Middle East & North Africa (all income levels)?
Your answer should be very brief. -29.39. What is the difference between the Gross enrolment ratio (%) in Pre-primary schools and Gross enrolment ratio (%) in Tertiary schools in Middle East & North Africa (all income levels)?
Offer a very short reply. 1.4. What is the difference between the Gross enrolment ratio (%) of Primary schools and Gross enrolment ratio (%) of Secondary schools in Middle East & North Africa (all income levels)?
Provide a succinct answer. 70.31. What is the difference between the Gross enrolment ratio (%) in Primary schools and Gross enrolment ratio (%) in Tertiary schools in Middle East & North Africa (all income levels)?
Your answer should be very brief. 101.1. What is the difference between the Gross enrolment ratio (%) in Secondary schools and Gross enrolment ratio (%) in Tertiary schools in Middle East & North Africa (all income levels)?
Your response must be concise. 30.79. What is the difference between the Gross enrolment ratio (%) in Pre-primary schools and Gross enrolment ratio (%) in Primary schools in Middle East & North Africa (developing only)?
Offer a terse response. -60.15. What is the difference between the Gross enrolment ratio (%) of Pre-primary schools and Gross enrolment ratio (%) of Secondary schools in Middle East & North Africa (developing only)?
Make the answer very short. -3.83. What is the difference between the Gross enrolment ratio (%) in Pre-primary schools and Gross enrolment ratio (%) in Tertiary schools in Middle East & North Africa (developing only)?
Make the answer very short. 6.95. What is the difference between the Gross enrolment ratio (%) of Primary schools and Gross enrolment ratio (%) of Secondary schools in Middle East & North Africa (developing only)?
Ensure brevity in your answer.  56.32. What is the difference between the Gross enrolment ratio (%) in Primary schools and Gross enrolment ratio (%) in Tertiary schools in Middle East & North Africa (developing only)?
Keep it short and to the point. 67.1. What is the difference between the Gross enrolment ratio (%) in Secondary schools and Gross enrolment ratio (%) in Tertiary schools in Middle East & North Africa (developing only)?
Keep it short and to the point. 10.79. What is the ratio of the Gross enrolment ratio (%) of Pre-primary schools in Least developed countries to that in Low & middle income?
Make the answer very short. 0.73. What is the ratio of the Gross enrolment ratio (%) of Primary schools in Least developed countries to that in Low & middle income?
Keep it short and to the point. 1.01. What is the ratio of the Gross enrolment ratio (%) of Secondary schools in Least developed countries to that in Low & middle income?
Provide a succinct answer. 2.53. What is the ratio of the Gross enrolment ratio (%) in Tertiary schools in Least developed countries to that in Low & middle income?
Offer a very short reply. 1.04. What is the ratio of the Gross enrolment ratio (%) of Pre-primary schools in Least developed countries to that in Low income?
Offer a very short reply. 1.15. What is the ratio of the Gross enrolment ratio (%) of Secondary schools in Least developed countries to that in Low income?
Your answer should be very brief. 2.73. What is the ratio of the Gross enrolment ratio (%) of Tertiary schools in Least developed countries to that in Low income?
Make the answer very short. 0.99. What is the ratio of the Gross enrolment ratio (%) of Pre-primary schools in Least developed countries to that in Lower middle income?
Provide a short and direct response. 0.46. What is the ratio of the Gross enrolment ratio (%) in Primary schools in Least developed countries to that in Lower middle income?
Your answer should be very brief. 0.91. What is the ratio of the Gross enrolment ratio (%) of Secondary schools in Least developed countries to that in Lower middle income?
Provide a succinct answer. 4.55. What is the ratio of the Gross enrolment ratio (%) of Tertiary schools in Least developed countries to that in Lower middle income?
Offer a very short reply. 3.1. What is the ratio of the Gross enrolment ratio (%) in Pre-primary schools in Least developed countries to that in Middle East & North Africa (all income levels)?
Keep it short and to the point. 0.56. What is the ratio of the Gross enrolment ratio (%) of Primary schools in Least developed countries to that in Middle East & North Africa (all income levels)?
Ensure brevity in your answer.  0.91. What is the ratio of the Gross enrolment ratio (%) of Secondary schools in Least developed countries to that in Middle East & North Africa (all income levels)?
Provide a succinct answer. 2.19. What is the ratio of the Gross enrolment ratio (%) in Tertiary schools in Least developed countries to that in Middle East & North Africa (all income levels)?
Provide a succinct answer. 3.65. What is the ratio of the Gross enrolment ratio (%) in Pre-primary schools in Least developed countries to that in Middle East & North Africa (developing only)?
Your response must be concise. 0.62. What is the ratio of the Gross enrolment ratio (%) of Primary schools in Least developed countries to that in Middle East & North Africa (developing only)?
Keep it short and to the point. 1.44. What is the ratio of the Gross enrolment ratio (%) in Secondary schools in Least developed countries to that in Middle East & North Africa (developing only)?
Give a very brief answer. 6.61. What is the ratio of the Gross enrolment ratio (%) in Tertiary schools in Least developed countries to that in Middle East & North Africa (developing only)?
Your response must be concise. 13.89. What is the ratio of the Gross enrolment ratio (%) in Pre-primary schools in Low & middle income to that in Low income?
Provide a succinct answer. 1.57. What is the ratio of the Gross enrolment ratio (%) in Primary schools in Low & middle income to that in Low income?
Give a very brief answer. 0.99. What is the ratio of the Gross enrolment ratio (%) in Secondary schools in Low & middle income to that in Low income?
Give a very brief answer. 1.08. What is the ratio of the Gross enrolment ratio (%) of Tertiary schools in Low & middle income to that in Low income?
Keep it short and to the point. 0.95. What is the ratio of the Gross enrolment ratio (%) of Pre-primary schools in Low & middle income to that in Lower middle income?
Ensure brevity in your answer.  0.62. What is the ratio of the Gross enrolment ratio (%) in Primary schools in Low & middle income to that in Lower middle income?
Your response must be concise. 0.91. What is the ratio of the Gross enrolment ratio (%) in Secondary schools in Low & middle income to that in Lower middle income?
Keep it short and to the point. 1.8. What is the ratio of the Gross enrolment ratio (%) in Tertiary schools in Low & middle income to that in Lower middle income?
Provide a succinct answer. 2.97. What is the ratio of the Gross enrolment ratio (%) in Pre-primary schools in Low & middle income to that in Middle East & North Africa (all income levels)?
Your response must be concise. 0.77. What is the ratio of the Gross enrolment ratio (%) in Primary schools in Low & middle income to that in Middle East & North Africa (all income levels)?
Provide a succinct answer. 0.9. What is the ratio of the Gross enrolment ratio (%) in Secondary schools in Low & middle income to that in Middle East & North Africa (all income levels)?
Offer a terse response. 0.86. What is the ratio of the Gross enrolment ratio (%) of Tertiary schools in Low & middle income to that in Middle East & North Africa (all income levels)?
Your answer should be very brief. 3.49. What is the ratio of the Gross enrolment ratio (%) of Pre-primary schools in Low & middle income to that in Middle East & North Africa (developing only)?
Your answer should be compact. 0.85. What is the ratio of the Gross enrolment ratio (%) in Primary schools in Low & middle income to that in Middle East & North Africa (developing only)?
Give a very brief answer. 1.43. What is the ratio of the Gross enrolment ratio (%) in Secondary schools in Low & middle income to that in Middle East & North Africa (developing only)?
Keep it short and to the point. 2.61. What is the ratio of the Gross enrolment ratio (%) in Tertiary schools in Low & middle income to that in Middle East & North Africa (developing only)?
Your answer should be very brief. 13.3. What is the ratio of the Gross enrolment ratio (%) in Pre-primary schools in Low income to that in Lower middle income?
Your answer should be compact. 0.4. What is the ratio of the Gross enrolment ratio (%) of Primary schools in Low income to that in Lower middle income?
Give a very brief answer. 0.91. What is the ratio of the Gross enrolment ratio (%) of Secondary schools in Low income to that in Lower middle income?
Keep it short and to the point. 1.67. What is the ratio of the Gross enrolment ratio (%) in Tertiary schools in Low income to that in Lower middle income?
Give a very brief answer. 3.13. What is the ratio of the Gross enrolment ratio (%) in Pre-primary schools in Low income to that in Middle East & North Africa (all income levels)?
Your answer should be compact. 0.49. What is the ratio of the Gross enrolment ratio (%) in Primary schools in Low income to that in Middle East & North Africa (all income levels)?
Give a very brief answer. 0.91. What is the ratio of the Gross enrolment ratio (%) in Secondary schools in Low income to that in Middle East & North Africa (all income levels)?
Offer a terse response. 0.8. What is the ratio of the Gross enrolment ratio (%) of Tertiary schools in Low income to that in Middle East & North Africa (all income levels)?
Make the answer very short. 3.69. What is the ratio of the Gross enrolment ratio (%) of Pre-primary schools in Low income to that in Middle East & North Africa (developing only)?
Provide a succinct answer. 0.54. What is the ratio of the Gross enrolment ratio (%) of Primary schools in Low income to that in Middle East & North Africa (developing only)?
Make the answer very short. 1.44. What is the ratio of the Gross enrolment ratio (%) in Secondary schools in Low income to that in Middle East & North Africa (developing only)?
Make the answer very short. 2.42. What is the ratio of the Gross enrolment ratio (%) of Tertiary schools in Low income to that in Middle East & North Africa (developing only)?
Give a very brief answer. 14.05. What is the ratio of the Gross enrolment ratio (%) of Pre-primary schools in Lower middle income to that in Middle East & North Africa (all income levels)?
Your answer should be compact. 1.23. What is the ratio of the Gross enrolment ratio (%) of Secondary schools in Lower middle income to that in Middle East & North Africa (all income levels)?
Provide a short and direct response. 0.48. What is the ratio of the Gross enrolment ratio (%) in Tertiary schools in Lower middle income to that in Middle East & North Africa (all income levels)?
Your answer should be compact. 1.18. What is the ratio of the Gross enrolment ratio (%) in Pre-primary schools in Lower middle income to that in Middle East & North Africa (developing only)?
Your answer should be very brief. 1.36. What is the ratio of the Gross enrolment ratio (%) in Primary schools in Lower middle income to that in Middle East & North Africa (developing only)?
Your answer should be compact. 1.58. What is the ratio of the Gross enrolment ratio (%) in Secondary schools in Lower middle income to that in Middle East & North Africa (developing only)?
Offer a terse response. 1.45. What is the ratio of the Gross enrolment ratio (%) of Tertiary schools in Lower middle income to that in Middle East & North Africa (developing only)?
Provide a short and direct response. 4.48. What is the ratio of the Gross enrolment ratio (%) of Pre-primary schools in Middle East & North Africa (all income levels) to that in Middle East & North Africa (developing only)?
Your answer should be very brief. 1.11. What is the ratio of the Gross enrolment ratio (%) of Primary schools in Middle East & North Africa (all income levels) to that in Middle East & North Africa (developing only)?
Ensure brevity in your answer.  1.58. What is the ratio of the Gross enrolment ratio (%) in Secondary schools in Middle East & North Africa (all income levels) to that in Middle East & North Africa (developing only)?
Your answer should be very brief. 3.02. What is the ratio of the Gross enrolment ratio (%) of Tertiary schools in Middle East & North Africa (all income levels) to that in Middle East & North Africa (developing only)?
Offer a terse response. 3.81. What is the difference between the highest and the second highest Gross enrolment ratio (%) in Pre-primary schools?
Give a very brief answer. 2.33. What is the difference between the highest and the second highest Gross enrolment ratio (%) of Primary schools?
Offer a terse response. 0.54. What is the difference between the highest and the second highest Gross enrolment ratio (%) of Secondary schools?
Provide a succinct answer. 47.12. What is the difference between the highest and the second highest Gross enrolment ratio (%) of Tertiary schools?
Give a very brief answer. 0.38. What is the difference between the highest and the lowest Gross enrolment ratio (%) in Pre-primary schools?
Keep it short and to the point. 7.63. What is the difference between the highest and the lowest Gross enrolment ratio (%) in Primary schools?
Your answer should be compact. 40.59. What is the difference between the highest and the lowest Gross enrolment ratio (%) in Secondary schools?
Your answer should be compact. 73.72. What is the difference between the highest and the lowest Gross enrolment ratio (%) of Tertiary schools?
Your answer should be compact. 30.63. 